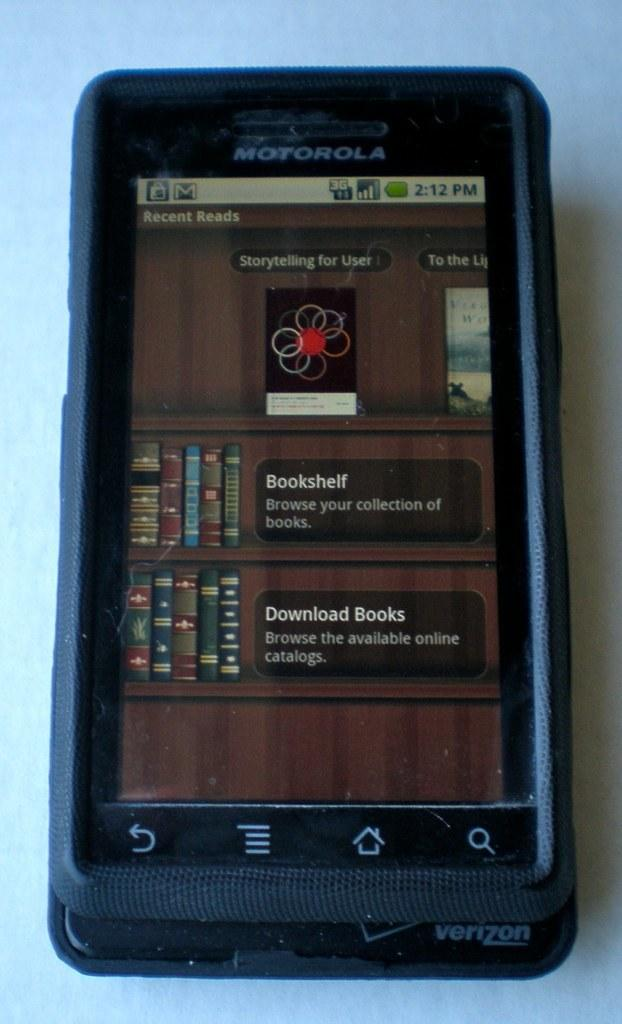<image>
Describe the image concisely. A Motorola phone that is showcasing recent reads and their bookshelf. 